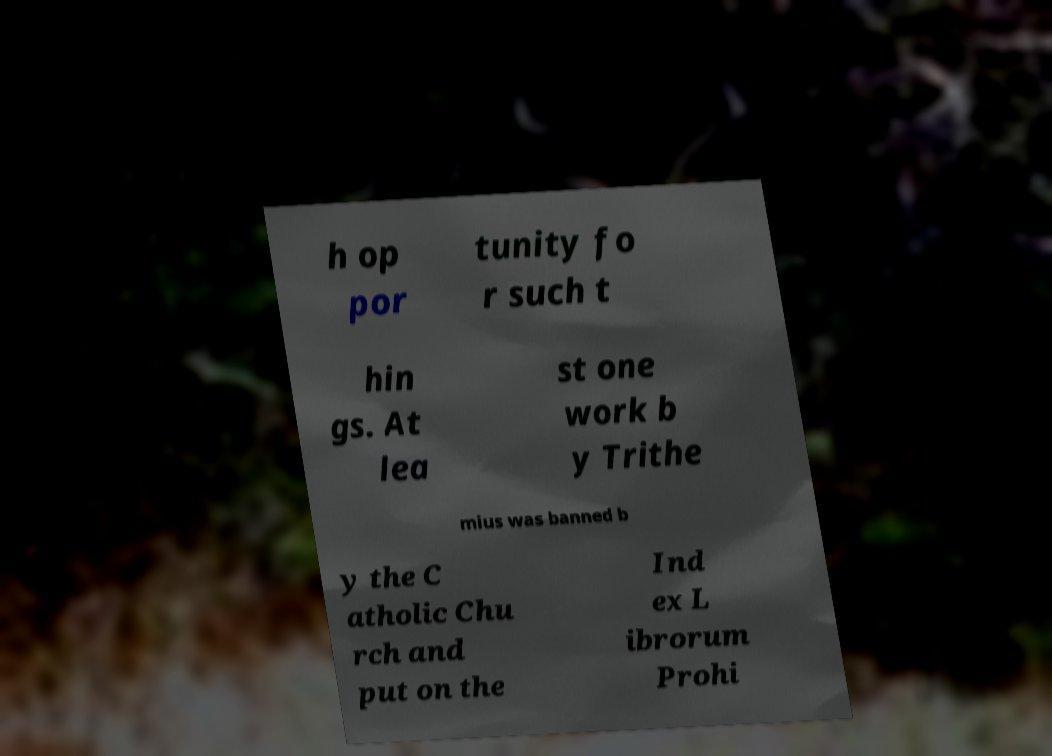Please identify and transcribe the text found in this image. h op por tunity fo r such t hin gs. At lea st one work b y Trithe mius was banned b y the C atholic Chu rch and put on the Ind ex L ibrorum Prohi 